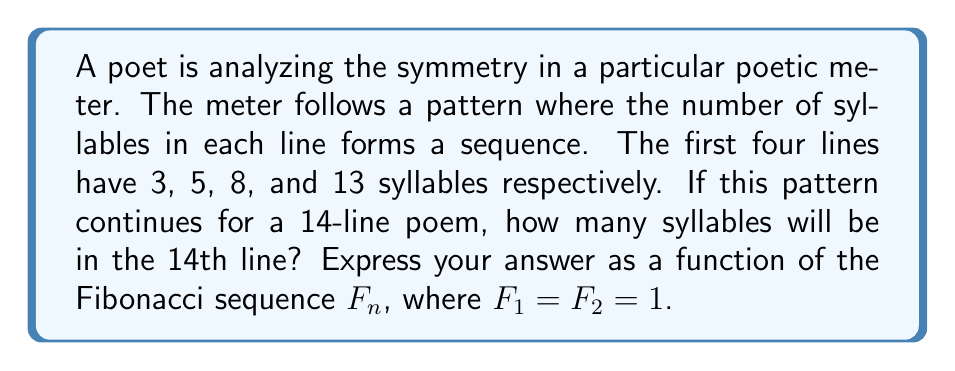Can you solve this math problem? To solve this problem, we need to recognize the pattern and relate it to the Fibonacci sequence. Let's break it down step-by-step:

1) The given syllable counts for the first four lines are 3, 5, 8, and 13.

2) This sequence follows the Fibonacci pattern, where each number is the sum of the two preceding ones.

3) We can relate these numbers to the Fibonacci sequence $F_n$ as follows:
   
   3 = $F_4$
   5 = $F_5$
   8 = $F_6$
   13 = $F_7$

4) We can see that the syllable count for line $n$ corresponds to $F_{n+3}$.

5) For a 14-line poem, we need to find $F_{14+3} = F_{17}$.

6) To calculate $F_{17}$, we can use the Fibonacci recurrence relation:
   
   $F_n = F_{n-1} + F_{n-2}$

7) Continuing the sequence:
   
   $F_8 = 21$
   $F_9 = 34$
   $F_{10} = 55$
   $F_{11} = 89$
   $F_{12} = 144$
   $F_{13} = 233$
   $F_{14} = 377$
   $F_{15} = 610$
   $F_{16} = 987$
   $F_{17} = 1597$

Therefore, the 14th line of the poem will have 1597 syllables, which can be expressed as $F_{17}$.
Answer: $F_{17}$ or 1597 syllables 